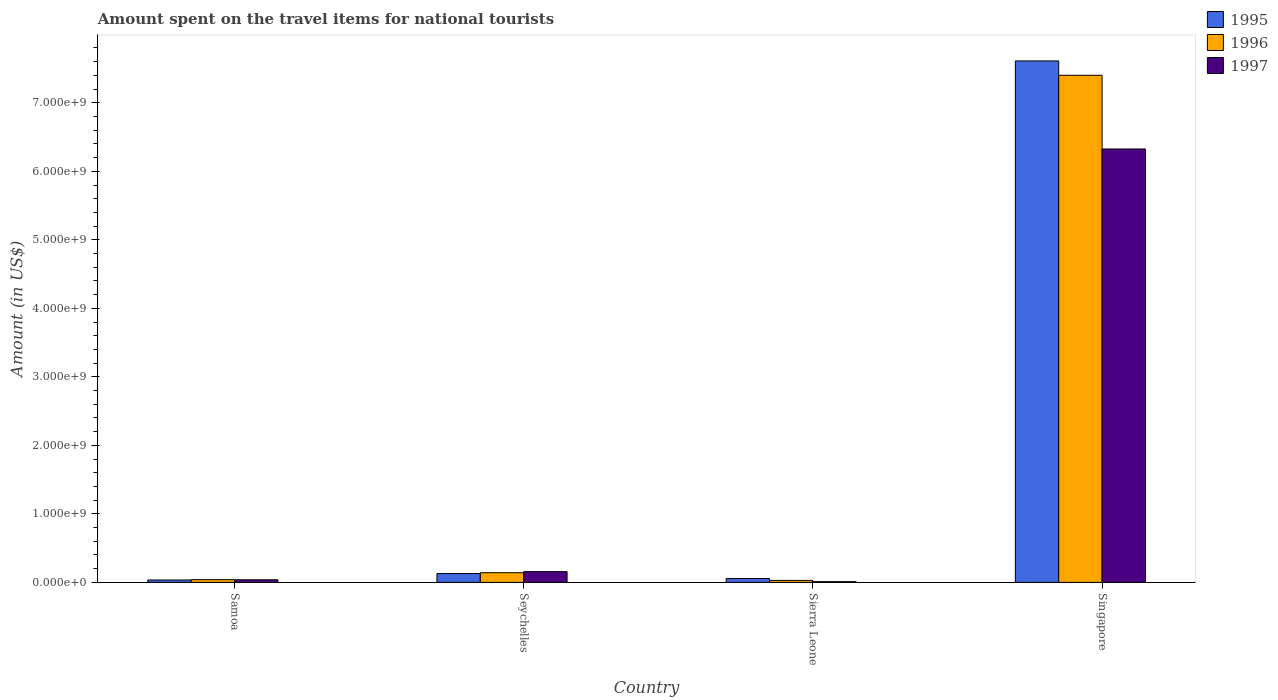How many groups of bars are there?
Offer a terse response. 4. What is the label of the 4th group of bars from the left?
Keep it short and to the point. Singapore. What is the amount spent on the travel items for national tourists in 1996 in Singapore?
Provide a succinct answer. 7.40e+09. Across all countries, what is the maximum amount spent on the travel items for national tourists in 1997?
Make the answer very short. 6.33e+09. Across all countries, what is the minimum amount spent on the travel items for national tourists in 1995?
Provide a succinct answer. 3.50e+07. In which country was the amount spent on the travel items for national tourists in 1996 maximum?
Provide a succinct answer. Singapore. In which country was the amount spent on the travel items for national tourists in 1995 minimum?
Provide a succinct answer. Samoa. What is the total amount spent on the travel items for national tourists in 1996 in the graph?
Keep it short and to the point. 7.61e+09. What is the difference between the amount spent on the travel items for national tourists in 1995 in Samoa and that in Seychelles?
Your answer should be very brief. -9.40e+07. What is the difference between the amount spent on the travel items for national tourists in 1995 in Seychelles and the amount spent on the travel items for national tourists in 1997 in Samoa?
Your answer should be compact. 9.10e+07. What is the average amount spent on the travel items for national tourists in 1996 per country?
Offer a terse response. 1.90e+09. What is the difference between the amount spent on the travel items for national tourists of/in 1995 and amount spent on the travel items for national tourists of/in 1997 in Singapore?
Give a very brief answer. 1.28e+09. In how many countries, is the amount spent on the travel items for national tourists in 1997 greater than 5800000000 US$?
Provide a succinct answer. 1. What is the ratio of the amount spent on the travel items for national tourists in 1995 in Sierra Leone to that in Singapore?
Ensure brevity in your answer.  0.01. Is the amount spent on the travel items for national tourists in 1996 in Seychelles less than that in Singapore?
Make the answer very short. Yes. What is the difference between the highest and the second highest amount spent on the travel items for national tourists in 1995?
Ensure brevity in your answer.  7.48e+09. What is the difference between the highest and the lowest amount spent on the travel items for national tourists in 1997?
Offer a very short reply. 6.32e+09. Is the sum of the amount spent on the travel items for national tourists in 1996 in Seychelles and Singapore greater than the maximum amount spent on the travel items for national tourists in 1995 across all countries?
Offer a very short reply. No. What does the 2nd bar from the right in Seychelles represents?
Keep it short and to the point. 1996. Are all the bars in the graph horizontal?
Offer a terse response. No. How many countries are there in the graph?
Your answer should be compact. 4. Does the graph contain any zero values?
Ensure brevity in your answer.  No. Where does the legend appear in the graph?
Your response must be concise. Top right. How are the legend labels stacked?
Your response must be concise. Vertical. What is the title of the graph?
Your answer should be compact. Amount spent on the travel items for national tourists. Does "1960" appear as one of the legend labels in the graph?
Keep it short and to the point. No. What is the Amount (in US$) of 1995 in Samoa?
Provide a short and direct response. 3.50e+07. What is the Amount (in US$) in 1996 in Samoa?
Ensure brevity in your answer.  4.00e+07. What is the Amount (in US$) of 1997 in Samoa?
Provide a short and direct response. 3.80e+07. What is the Amount (in US$) of 1995 in Seychelles?
Offer a very short reply. 1.29e+08. What is the Amount (in US$) in 1996 in Seychelles?
Ensure brevity in your answer.  1.41e+08. What is the Amount (in US$) of 1997 in Seychelles?
Keep it short and to the point. 1.57e+08. What is the Amount (in US$) of 1995 in Sierra Leone?
Offer a very short reply. 5.70e+07. What is the Amount (in US$) of 1996 in Sierra Leone?
Make the answer very short. 2.90e+07. What is the Amount (in US$) of 1995 in Singapore?
Offer a terse response. 7.61e+09. What is the Amount (in US$) of 1996 in Singapore?
Keep it short and to the point. 7.40e+09. What is the Amount (in US$) in 1997 in Singapore?
Offer a terse response. 6.33e+09. Across all countries, what is the maximum Amount (in US$) of 1995?
Your answer should be compact. 7.61e+09. Across all countries, what is the maximum Amount (in US$) of 1996?
Keep it short and to the point. 7.40e+09. Across all countries, what is the maximum Amount (in US$) of 1997?
Provide a succinct answer. 6.33e+09. Across all countries, what is the minimum Amount (in US$) of 1995?
Give a very brief answer. 3.50e+07. Across all countries, what is the minimum Amount (in US$) of 1996?
Keep it short and to the point. 2.90e+07. Across all countries, what is the minimum Amount (in US$) of 1997?
Your answer should be compact. 1.00e+07. What is the total Amount (in US$) in 1995 in the graph?
Provide a short and direct response. 7.83e+09. What is the total Amount (in US$) of 1996 in the graph?
Give a very brief answer. 7.61e+09. What is the total Amount (in US$) of 1997 in the graph?
Your answer should be compact. 6.53e+09. What is the difference between the Amount (in US$) in 1995 in Samoa and that in Seychelles?
Ensure brevity in your answer.  -9.40e+07. What is the difference between the Amount (in US$) of 1996 in Samoa and that in Seychelles?
Provide a succinct answer. -1.01e+08. What is the difference between the Amount (in US$) of 1997 in Samoa and that in Seychelles?
Your answer should be compact. -1.19e+08. What is the difference between the Amount (in US$) in 1995 in Samoa and that in Sierra Leone?
Provide a short and direct response. -2.20e+07. What is the difference between the Amount (in US$) in 1996 in Samoa and that in Sierra Leone?
Offer a terse response. 1.10e+07. What is the difference between the Amount (in US$) of 1997 in Samoa and that in Sierra Leone?
Ensure brevity in your answer.  2.80e+07. What is the difference between the Amount (in US$) in 1995 in Samoa and that in Singapore?
Your answer should be compact. -7.58e+09. What is the difference between the Amount (in US$) of 1996 in Samoa and that in Singapore?
Keep it short and to the point. -7.36e+09. What is the difference between the Amount (in US$) in 1997 in Samoa and that in Singapore?
Offer a terse response. -6.29e+09. What is the difference between the Amount (in US$) in 1995 in Seychelles and that in Sierra Leone?
Make the answer very short. 7.20e+07. What is the difference between the Amount (in US$) of 1996 in Seychelles and that in Sierra Leone?
Your response must be concise. 1.12e+08. What is the difference between the Amount (in US$) of 1997 in Seychelles and that in Sierra Leone?
Offer a very short reply. 1.47e+08. What is the difference between the Amount (in US$) in 1995 in Seychelles and that in Singapore?
Ensure brevity in your answer.  -7.48e+09. What is the difference between the Amount (in US$) of 1996 in Seychelles and that in Singapore?
Offer a terse response. -7.26e+09. What is the difference between the Amount (in US$) in 1997 in Seychelles and that in Singapore?
Make the answer very short. -6.17e+09. What is the difference between the Amount (in US$) of 1995 in Sierra Leone and that in Singapore?
Provide a short and direct response. -7.55e+09. What is the difference between the Amount (in US$) in 1996 in Sierra Leone and that in Singapore?
Your response must be concise. -7.37e+09. What is the difference between the Amount (in US$) in 1997 in Sierra Leone and that in Singapore?
Your answer should be compact. -6.32e+09. What is the difference between the Amount (in US$) of 1995 in Samoa and the Amount (in US$) of 1996 in Seychelles?
Ensure brevity in your answer.  -1.06e+08. What is the difference between the Amount (in US$) in 1995 in Samoa and the Amount (in US$) in 1997 in Seychelles?
Offer a terse response. -1.22e+08. What is the difference between the Amount (in US$) of 1996 in Samoa and the Amount (in US$) of 1997 in Seychelles?
Provide a succinct answer. -1.17e+08. What is the difference between the Amount (in US$) of 1995 in Samoa and the Amount (in US$) of 1997 in Sierra Leone?
Your answer should be very brief. 2.50e+07. What is the difference between the Amount (in US$) in 1996 in Samoa and the Amount (in US$) in 1997 in Sierra Leone?
Your answer should be compact. 3.00e+07. What is the difference between the Amount (in US$) in 1995 in Samoa and the Amount (in US$) in 1996 in Singapore?
Offer a terse response. -7.37e+09. What is the difference between the Amount (in US$) in 1995 in Samoa and the Amount (in US$) in 1997 in Singapore?
Make the answer very short. -6.29e+09. What is the difference between the Amount (in US$) in 1996 in Samoa and the Amount (in US$) in 1997 in Singapore?
Offer a very short reply. -6.29e+09. What is the difference between the Amount (in US$) of 1995 in Seychelles and the Amount (in US$) of 1997 in Sierra Leone?
Give a very brief answer. 1.19e+08. What is the difference between the Amount (in US$) of 1996 in Seychelles and the Amount (in US$) of 1997 in Sierra Leone?
Your response must be concise. 1.31e+08. What is the difference between the Amount (in US$) of 1995 in Seychelles and the Amount (in US$) of 1996 in Singapore?
Offer a terse response. -7.27e+09. What is the difference between the Amount (in US$) of 1995 in Seychelles and the Amount (in US$) of 1997 in Singapore?
Give a very brief answer. -6.20e+09. What is the difference between the Amount (in US$) of 1996 in Seychelles and the Amount (in US$) of 1997 in Singapore?
Make the answer very short. -6.18e+09. What is the difference between the Amount (in US$) in 1995 in Sierra Leone and the Amount (in US$) in 1996 in Singapore?
Provide a succinct answer. -7.34e+09. What is the difference between the Amount (in US$) of 1995 in Sierra Leone and the Amount (in US$) of 1997 in Singapore?
Your response must be concise. -6.27e+09. What is the difference between the Amount (in US$) in 1996 in Sierra Leone and the Amount (in US$) in 1997 in Singapore?
Offer a very short reply. -6.30e+09. What is the average Amount (in US$) of 1995 per country?
Your answer should be compact. 1.96e+09. What is the average Amount (in US$) of 1996 per country?
Give a very brief answer. 1.90e+09. What is the average Amount (in US$) of 1997 per country?
Keep it short and to the point. 1.63e+09. What is the difference between the Amount (in US$) of 1995 and Amount (in US$) of 1996 in Samoa?
Provide a succinct answer. -5.00e+06. What is the difference between the Amount (in US$) in 1995 and Amount (in US$) in 1996 in Seychelles?
Make the answer very short. -1.20e+07. What is the difference between the Amount (in US$) of 1995 and Amount (in US$) of 1997 in Seychelles?
Give a very brief answer. -2.80e+07. What is the difference between the Amount (in US$) of 1996 and Amount (in US$) of 1997 in Seychelles?
Provide a short and direct response. -1.60e+07. What is the difference between the Amount (in US$) in 1995 and Amount (in US$) in 1996 in Sierra Leone?
Offer a very short reply. 2.80e+07. What is the difference between the Amount (in US$) of 1995 and Amount (in US$) of 1997 in Sierra Leone?
Keep it short and to the point. 4.70e+07. What is the difference between the Amount (in US$) in 1996 and Amount (in US$) in 1997 in Sierra Leone?
Your answer should be compact. 1.90e+07. What is the difference between the Amount (in US$) in 1995 and Amount (in US$) in 1996 in Singapore?
Offer a very short reply. 2.09e+08. What is the difference between the Amount (in US$) in 1995 and Amount (in US$) in 1997 in Singapore?
Your answer should be compact. 1.28e+09. What is the difference between the Amount (in US$) of 1996 and Amount (in US$) of 1997 in Singapore?
Make the answer very short. 1.08e+09. What is the ratio of the Amount (in US$) of 1995 in Samoa to that in Seychelles?
Provide a short and direct response. 0.27. What is the ratio of the Amount (in US$) of 1996 in Samoa to that in Seychelles?
Provide a succinct answer. 0.28. What is the ratio of the Amount (in US$) of 1997 in Samoa to that in Seychelles?
Your answer should be compact. 0.24. What is the ratio of the Amount (in US$) in 1995 in Samoa to that in Sierra Leone?
Ensure brevity in your answer.  0.61. What is the ratio of the Amount (in US$) of 1996 in Samoa to that in Sierra Leone?
Give a very brief answer. 1.38. What is the ratio of the Amount (in US$) of 1997 in Samoa to that in Sierra Leone?
Provide a succinct answer. 3.8. What is the ratio of the Amount (in US$) of 1995 in Samoa to that in Singapore?
Offer a terse response. 0. What is the ratio of the Amount (in US$) in 1996 in Samoa to that in Singapore?
Give a very brief answer. 0.01. What is the ratio of the Amount (in US$) of 1997 in Samoa to that in Singapore?
Offer a very short reply. 0.01. What is the ratio of the Amount (in US$) of 1995 in Seychelles to that in Sierra Leone?
Make the answer very short. 2.26. What is the ratio of the Amount (in US$) of 1996 in Seychelles to that in Sierra Leone?
Provide a succinct answer. 4.86. What is the ratio of the Amount (in US$) in 1995 in Seychelles to that in Singapore?
Your answer should be compact. 0.02. What is the ratio of the Amount (in US$) in 1996 in Seychelles to that in Singapore?
Offer a very short reply. 0.02. What is the ratio of the Amount (in US$) of 1997 in Seychelles to that in Singapore?
Ensure brevity in your answer.  0.02. What is the ratio of the Amount (in US$) in 1995 in Sierra Leone to that in Singapore?
Provide a short and direct response. 0.01. What is the ratio of the Amount (in US$) in 1996 in Sierra Leone to that in Singapore?
Ensure brevity in your answer.  0. What is the ratio of the Amount (in US$) in 1997 in Sierra Leone to that in Singapore?
Provide a succinct answer. 0. What is the difference between the highest and the second highest Amount (in US$) in 1995?
Offer a terse response. 7.48e+09. What is the difference between the highest and the second highest Amount (in US$) in 1996?
Offer a very short reply. 7.26e+09. What is the difference between the highest and the second highest Amount (in US$) of 1997?
Offer a very short reply. 6.17e+09. What is the difference between the highest and the lowest Amount (in US$) in 1995?
Give a very brief answer. 7.58e+09. What is the difference between the highest and the lowest Amount (in US$) in 1996?
Your response must be concise. 7.37e+09. What is the difference between the highest and the lowest Amount (in US$) in 1997?
Your response must be concise. 6.32e+09. 